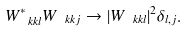<formula> <loc_0><loc_0><loc_500><loc_500>W _ { \ k k l } ^ { * } W _ { \ k k j } \rightarrow | W _ { \ k k l } | ^ { 2 } \delta _ { l , j } .</formula> 